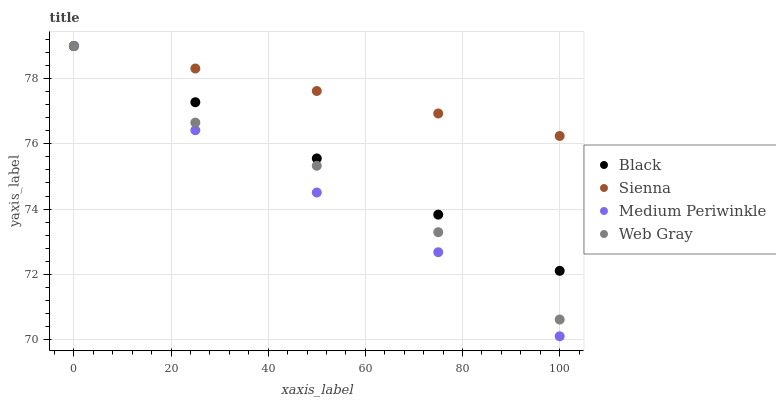Does Medium Periwinkle have the minimum area under the curve?
Answer yes or no. Yes. Does Sienna have the maximum area under the curve?
Answer yes or no. Yes. Does Web Gray have the minimum area under the curve?
Answer yes or no. No. Does Web Gray have the maximum area under the curve?
Answer yes or no. No. Is Sienna the smoothest?
Answer yes or no. Yes. Is Web Gray the roughest?
Answer yes or no. Yes. Is Medium Periwinkle the smoothest?
Answer yes or no. No. Is Medium Periwinkle the roughest?
Answer yes or no. No. Does Medium Periwinkle have the lowest value?
Answer yes or no. Yes. Does Web Gray have the lowest value?
Answer yes or no. No. Does Black have the highest value?
Answer yes or no. Yes. Does Medium Periwinkle intersect Web Gray?
Answer yes or no. Yes. Is Medium Periwinkle less than Web Gray?
Answer yes or no. No. Is Medium Periwinkle greater than Web Gray?
Answer yes or no. No. 